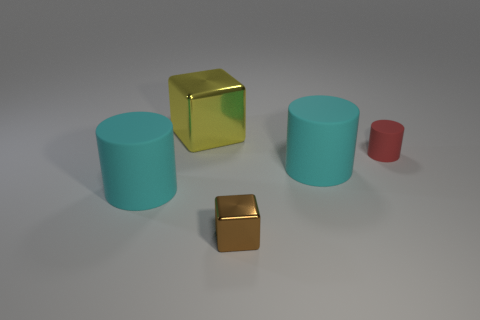What number of tiny red cylinders are to the right of the yellow object?
Give a very brief answer. 1. There is a cyan object that is to the left of the yellow metal object; is it the same size as the cube that is behind the red matte object?
Make the answer very short. Yes. How many other objects are there of the same size as the brown shiny block?
Keep it short and to the point. 1. What is the material of the cyan cylinder that is on the right side of the big cylinder on the left side of the cyan rubber thing right of the small shiny object?
Your answer should be very brief. Rubber. There is a red rubber cylinder; is its size the same as the shiny object to the right of the big block?
Make the answer very short. Yes. Are there any shiny things of the same color as the small rubber thing?
Provide a short and direct response. No. The large rubber object behind the cyan thing that is to the left of the tiny metal object is what color?
Your answer should be very brief. Cyan. Is the number of brown blocks that are left of the tiny metal block less than the number of brown metallic blocks in front of the tiny red thing?
Make the answer very short. Yes. Does the brown thing have the same size as the red rubber cylinder?
Offer a very short reply. Yes. There is a rubber object that is on the right side of the yellow metallic object and in front of the tiny cylinder; what is its shape?
Your answer should be compact. Cylinder. 